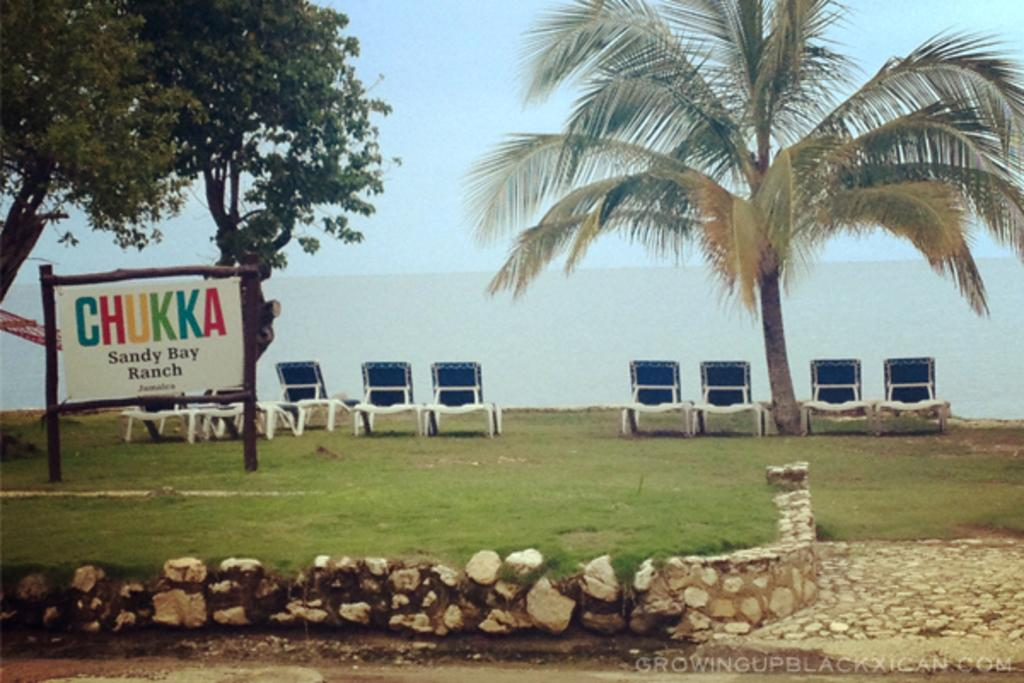What type of structure can be seen in the image? There is a wall in the image. What type of vegetation is present in the image? There is grass in the image. What is the board on wooden poles used for in the image? The board on wooden poles might be used for displaying information or notices. What other natural elements can be seen in the image? There are trees in the image. What type of furniture is present in the image? There are chairs in the image. What can be seen in the background of the image? Water and the sky are visible in the background of the image. What is the father's reaction to the anger displayed by the train in the image? There is no father, anger, or train present in the image. 